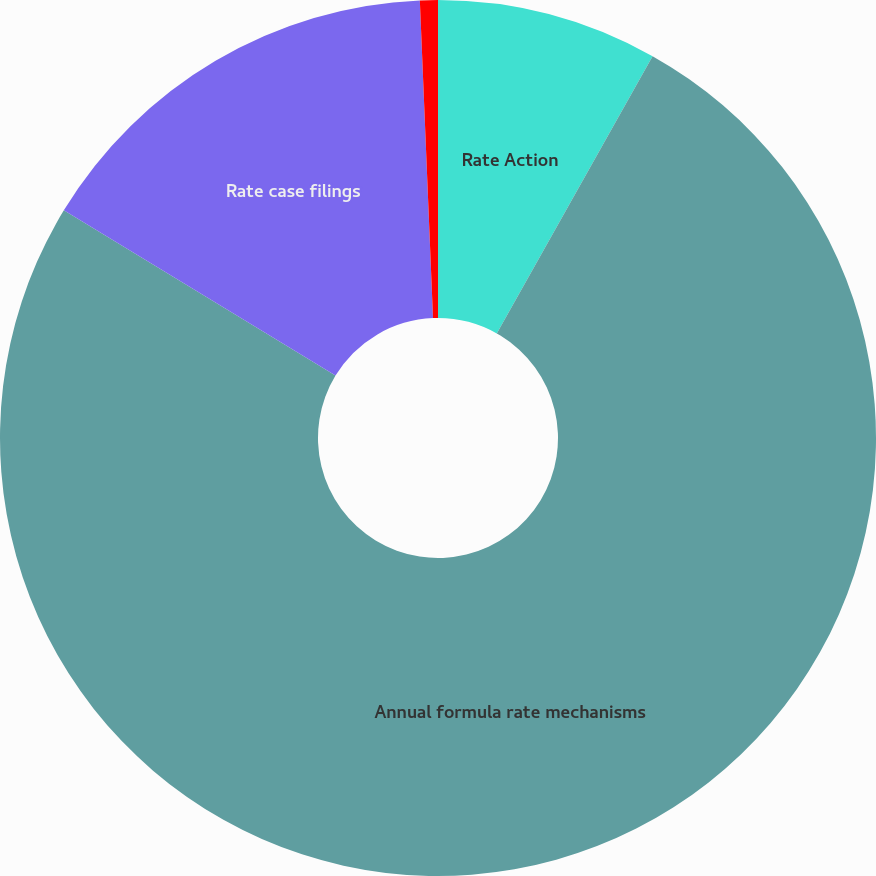Convert chart. <chart><loc_0><loc_0><loc_500><loc_500><pie_chart><fcel>Rate Action<fcel>Annual formula rate mechanisms<fcel>Rate case filings<fcel>Other ratemaking activity<nl><fcel>8.15%<fcel>75.56%<fcel>15.64%<fcel>0.66%<nl></chart> 